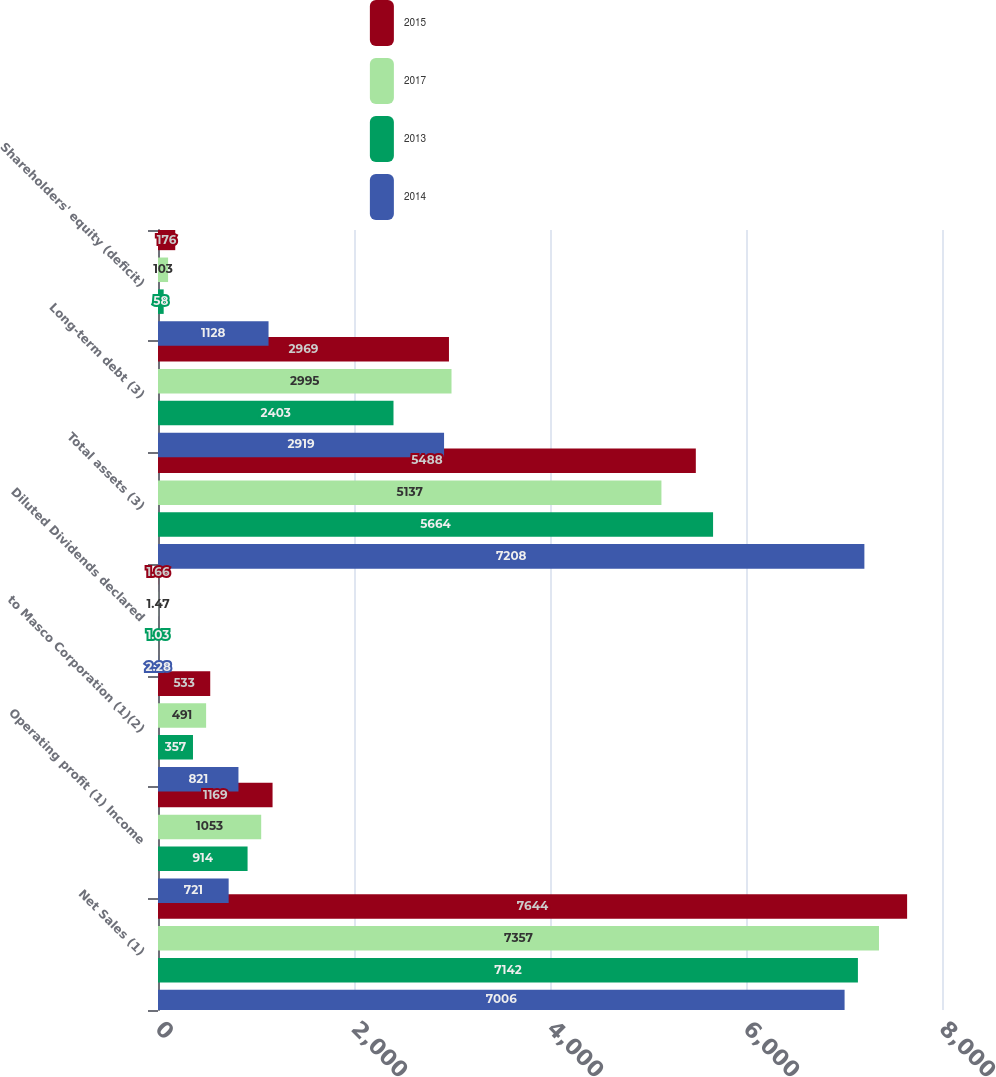<chart> <loc_0><loc_0><loc_500><loc_500><stacked_bar_chart><ecel><fcel>Net Sales (1)<fcel>Operating profit (1) Income<fcel>to Masco Corporation (1)(2)<fcel>Diluted Dividends declared<fcel>Total assets (3)<fcel>Long-term debt (3)<fcel>Shareholders' equity (deficit)<nl><fcel>2015<fcel>7644<fcel>1169<fcel>533<fcel>1.66<fcel>5488<fcel>2969<fcel>176<nl><fcel>2017<fcel>7357<fcel>1053<fcel>491<fcel>1.47<fcel>5137<fcel>2995<fcel>103<nl><fcel>2013<fcel>7142<fcel>914<fcel>357<fcel>1.03<fcel>5664<fcel>2403<fcel>58<nl><fcel>2014<fcel>7006<fcel>721<fcel>821<fcel>2.28<fcel>7208<fcel>2919<fcel>1128<nl></chart> 